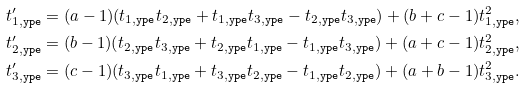Convert formula to latex. <formula><loc_0><loc_0><loc_500><loc_500>t _ { 1 , \tt y p e } ^ { \prime } = ( a - 1 ) ( t _ { 1 , \tt y p e } t _ { 2 , \tt y p e } + t _ { 1 , \tt y p e } t _ { 3 , \tt y p e } - t _ { 2 , \tt y p e } t _ { 3 , \tt y p e } ) + ( b + c - 1 ) t _ { 1 , \tt y p e } ^ { 2 } , \\ t _ { 2 , \tt y p e } ^ { \prime } = ( b - 1 ) ( t _ { 2 , \tt y p e } t _ { 3 , \tt y p e } + t _ { 2 , \tt y p e } t _ { 1 , \tt y p e } - t _ { 1 , \tt y p e } t _ { 3 , \tt y p e } ) + ( a + c - 1 ) t _ { 2 , \tt y p e } ^ { 2 } , \\ t _ { 3 , \tt y p e } ^ { \prime } = ( c - 1 ) ( t _ { 3 , \tt y p e } t _ { 1 , \tt y p e } + t _ { 3 , \tt y p e } t _ { 2 , \tt y p e } - t _ { 1 , \tt y p e } t _ { 2 , \tt y p e } ) + ( a + b - 1 ) t _ { 3 , \tt y p e } ^ { 2 } .</formula> 